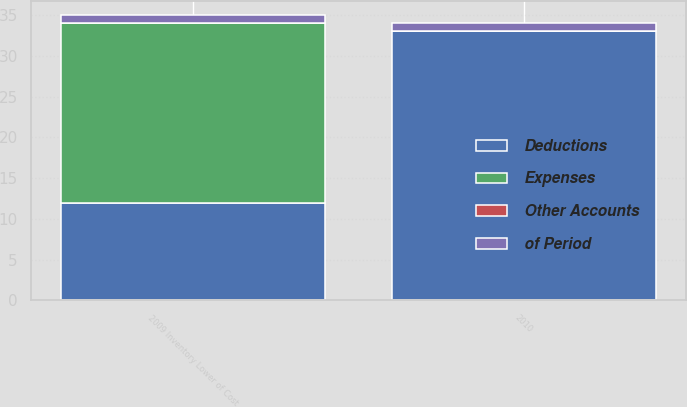Convert chart. <chart><loc_0><loc_0><loc_500><loc_500><stacked_bar_chart><ecel><fcel>2010<fcel>2009 Inventory Lower of Cost<nl><fcel>Deductions<fcel>33<fcel>12<nl><fcel>Expenses<fcel>0<fcel>22<nl><fcel>Other Accounts<fcel>0<fcel>0<nl><fcel>of Period<fcel>1<fcel>1<nl></chart> 